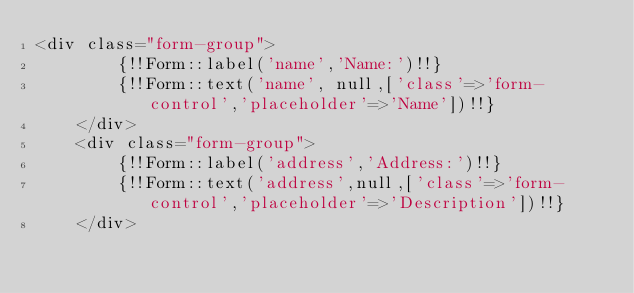Convert code to text. <code><loc_0><loc_0><loc_500><loc_500><_PHP_><div class="form-group">
		{!!Form::label('name','Name:')!!}
		{!!Form::text('name', null,['class'=>'form-control','placeholder'=>'Name'])!!}
	</div>
	<div class="form-group">
		{!!Form::label('address','Address:')!!}
		{!!Form::text('address',null,['class'=>'form-control','placeholder'=>'Description'])!!}
	</div>
</code> 